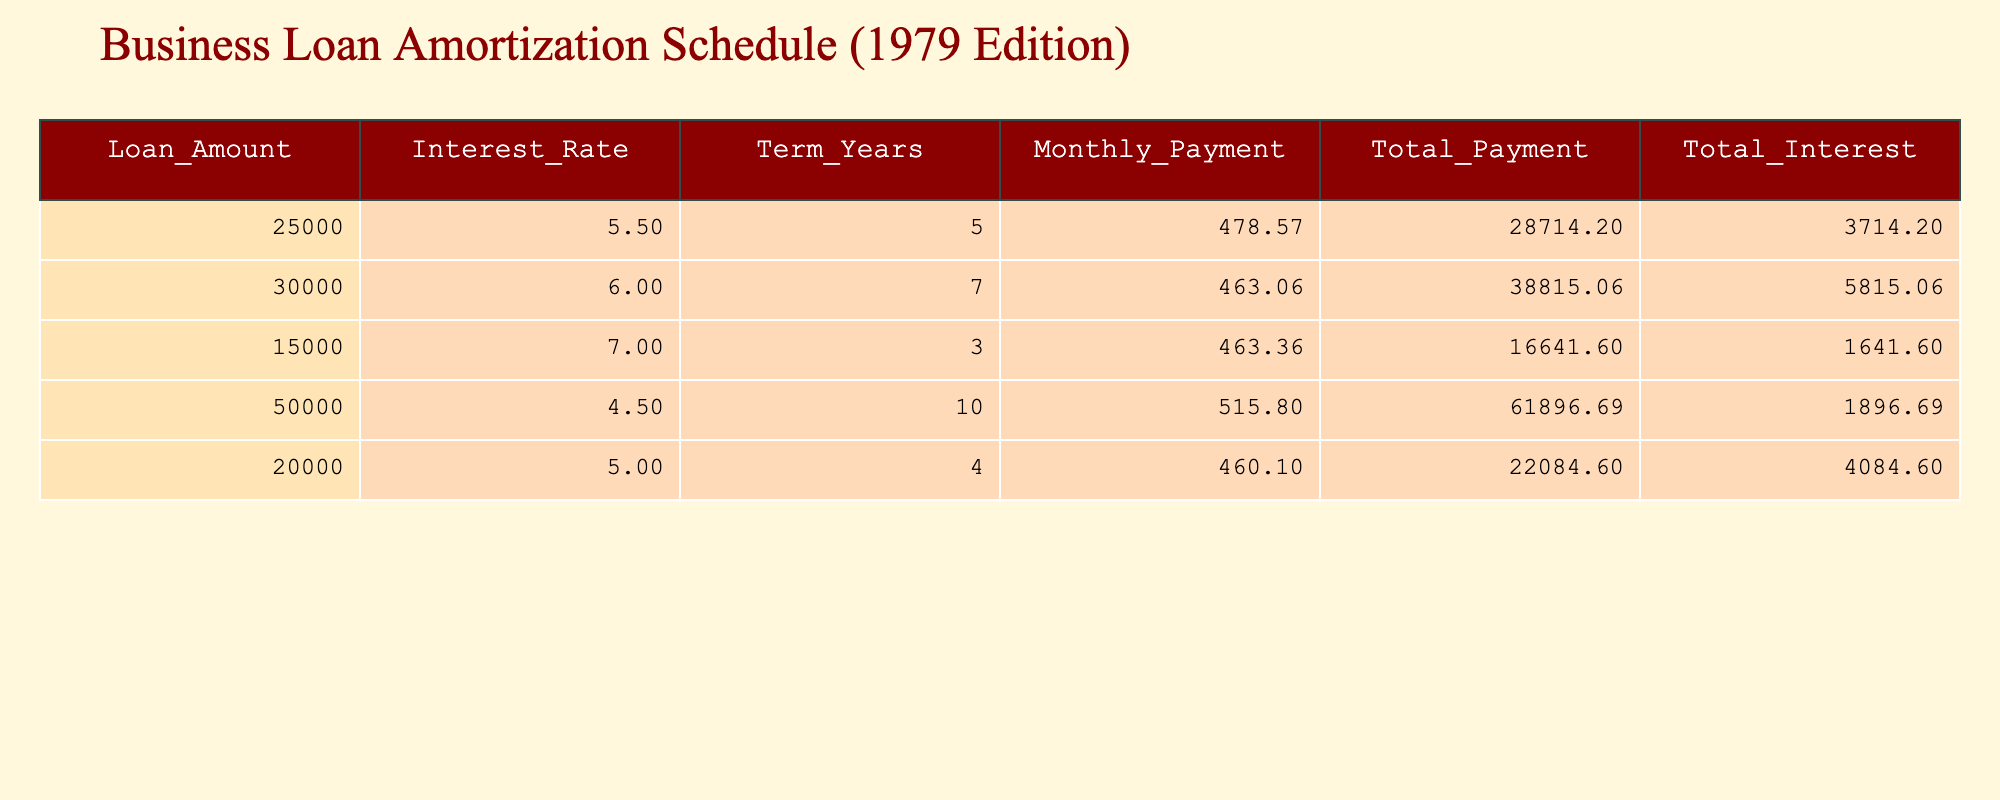What is the loan amount with the highest total payment? From the table, the total payments for each loan are: 28714.20, 38815.06, 16641.60, 61896.69, and 22084.60. The highest among these is 61896.69, which corresponds to the loan amount of 50000.
Answer: 50000 How much total interest will be paid on a 15000 loan? The total interest for the 15000 loan is clearly provided in the table, which states it as 1641.60.
Answer: 1641.60 Is the interest rate for the 20000 loan higher than the interest rate for the 25000 loan? The interest rate for the 20000 loan is 5.0, while the interest rate for the 25000 loan is 5.5. Since 5.0 is less than 5.5, the statement is false.
Answer: No What is the average monthly payment for all of the loans? To calculate the average monthly payment, first sum the monthly payments: 478.57 + 463.06 + 463.36 + 515.80 + 460.10 = 2380.89. Then, divide by the number of loans, which is 5. Thus, the average is 2380.89 / 5 = 476.18.
Answer: 476.18 If a business takes the highest loan amount, how much must it pay in total interest? The loan with the highest amount is 50000, and the total interest for this loan is listed in the table as 1896.69.
Answer: 1896.69 Are there any loans with an interest rate over 6%? Checking the interest rates in the table: the rates are 5.5, 6.0, 7.0, 4.5, and 5.0. Since 7.0 is greater than 6%, this statement is true.
Answer: Yes What is the difference in total payments between the 30000 loan and the 50000 loan? The total payment for the 30000 loan is 38815.06, and for the 50000 loan, it is 61896.69. To find the difference, subtract: 61896.69 - 38815.06 = 23081.63.
Answer: 23081.63 How long is the term for the loan with the highest monthly payment? The monthly payment for each loan is: 478.57, 463.06, 463.36, 515.80, and 460.10. The highest monthly payment is 515.80, corresponding to the 50000 loan, which has a term of 10 years.
Answer: 10 years 